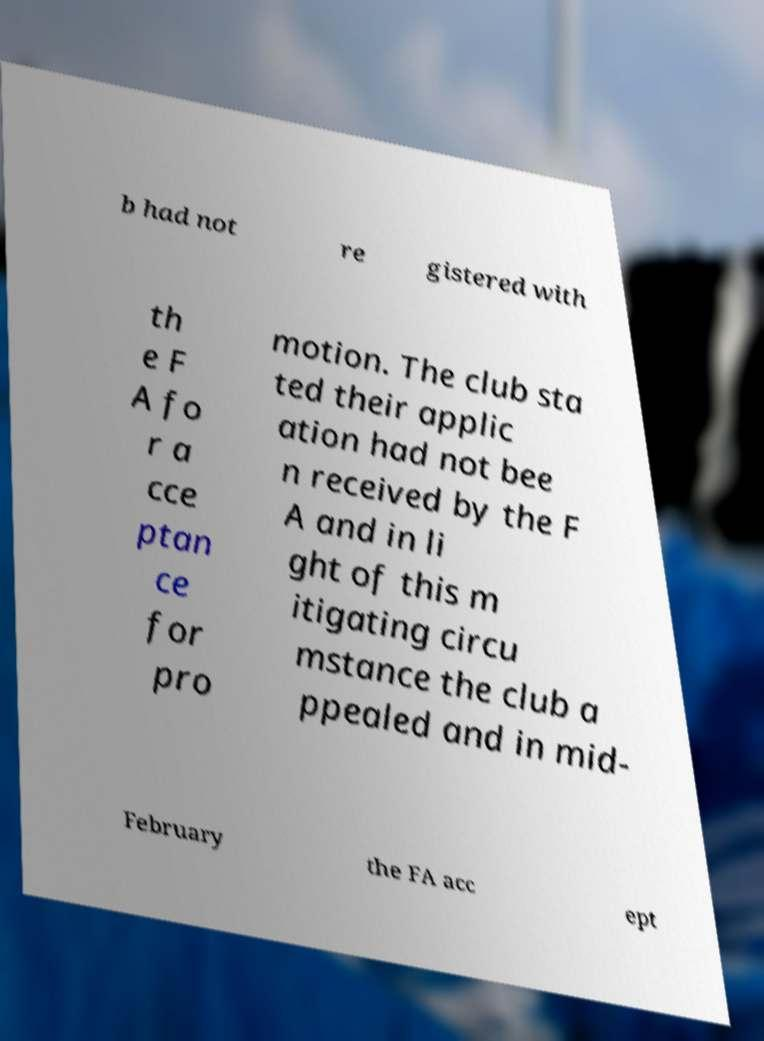Please read and relay the text visible in this image. What does it say? b had not re gistered with th e F A fo r a cce ptan ce for pro motion. The club sta ted their applic ation had not bee n received by the F A and in li ght of this m itigating circu mstance the club a ppealed and in mid- February the FA acc ept 